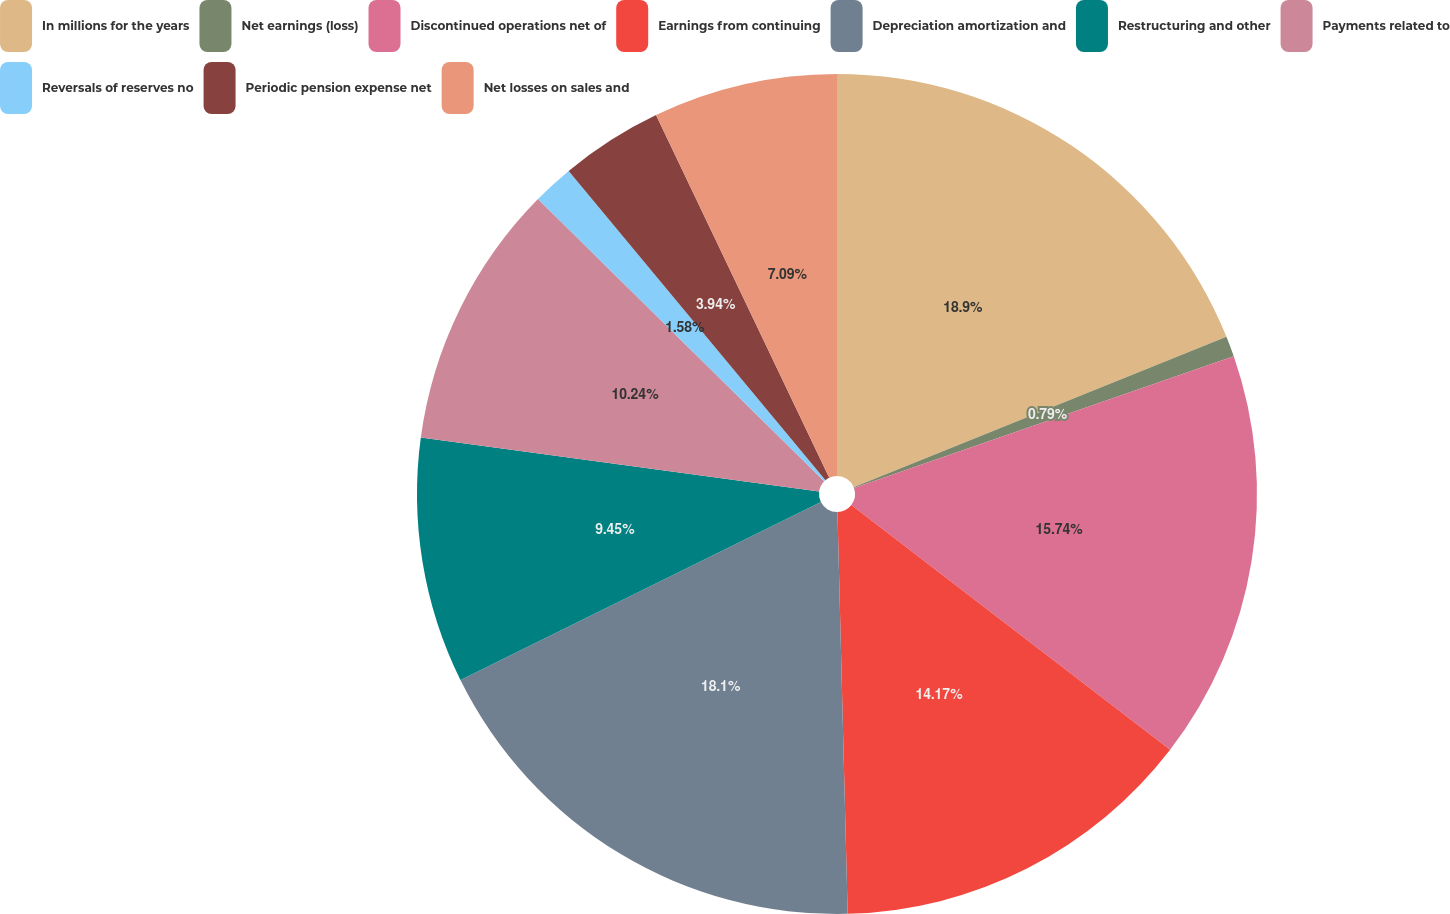<chart> <loc_0><loc_0><loc_500><loc_500><pie_chart><fcel>In millions for the years<fcel>Net earnings (loss)<fcel>Discontinued operations net of<fcel>Earnings from continuing<fcel>Depreciation amortization and<fcel>Restructuring and other<fcel>Payments related to<fcel>Reversals of reserves no<fcel>Periodic pension expense net<fcel>Net losses on sales and<nl><fcel>18.89%<fcel>0.79%<fcel>15.74%<fcel>14.17%<fcel>18.1%<fcel>9.45%<fcel>10.24%<fcel>1.58%<fcel>3.94%<fcel>7.09%<nl></chart> 